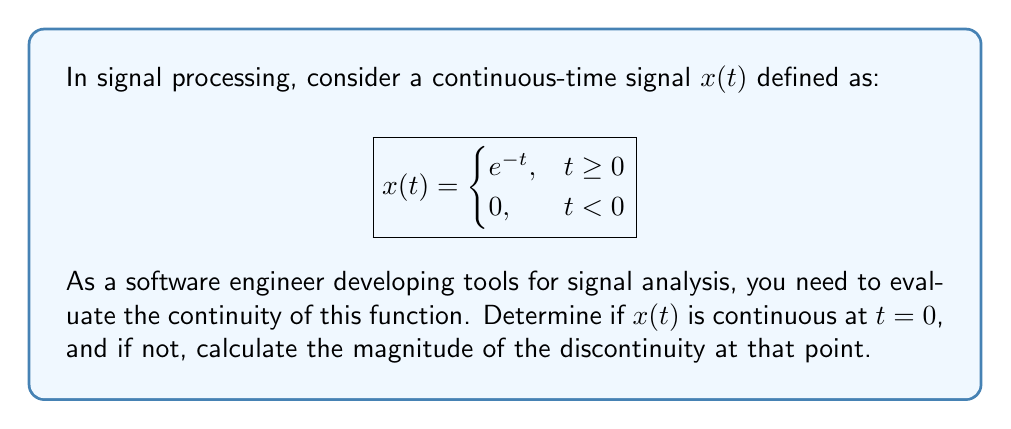Can you solve this math problem? To evaluate the continuity of the function $x(t)$ at $t = 0$, we need to check three conditions:

1. The function must be defined at $t = 0$
2. The limit of the function as $t$ approaches 0 from the right must exist
3. The limit of the function as $t$ approaches 0 from the left must exist
4. Both limits must be equal to the function value at $t = 0$

Let's check these conditions step by step:

1. The function is defined at $t = 0$:
   $x(0) = e^0 = 1$ (using the first piece of the piecewise function)

2. Right-hand limit:
   $\lim_{t \to 0^+} x(t) = \lim_{t \to 0^+} e^{-t} = e^0 = 1$

3. Left-hand limit:
   $\lim_{t \to 0^-} x(t) = \lim_{t \to 0^-} 0 = 0$

4. Comparing limits:
   We can see that the left-hand limit (0) is not equal to the right-hand limit (1).

Since the left-hand and right-hand limits are not equal, the function is not continuous at $t = 0$. This type of discontinuity is called a jump discontinuity.

To calculate the magnitude of the discontinuity, we need to find the difference between the right-hand and left-hand limits:

Magnitude of discontinuity = $|\lim_{t \to 0^+} x(t) - \lim_{t \to 0^-} x(t)|$
                            = $|1 - 0|$
                            = $1$

This discontinuity is important in signal processing as it represents an abrupt change in the signal at $t = 0$, which can have implications for frequency analysis and filtering operations.
Answer: The function $x(t)$ is not continuous at $t = 0$. It has a jump discontinuity with a magnitude of 1. 